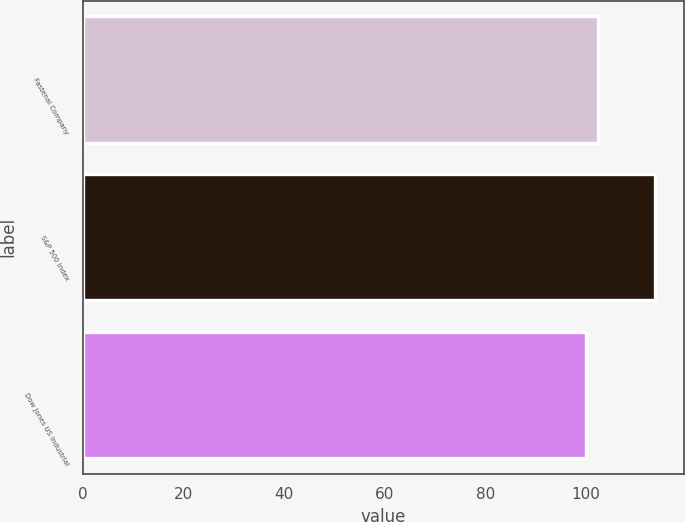Convert chart. <chart><loc_0><loc_0><loc_500><loc_500><bar_chart><fcel>Fastenal Company<fcel>S&P 500 Index<fcel>Dow Jones US Industrial<nl><fcel>102.36<fcel>113.69<fcel>99.94<nl></chart> 